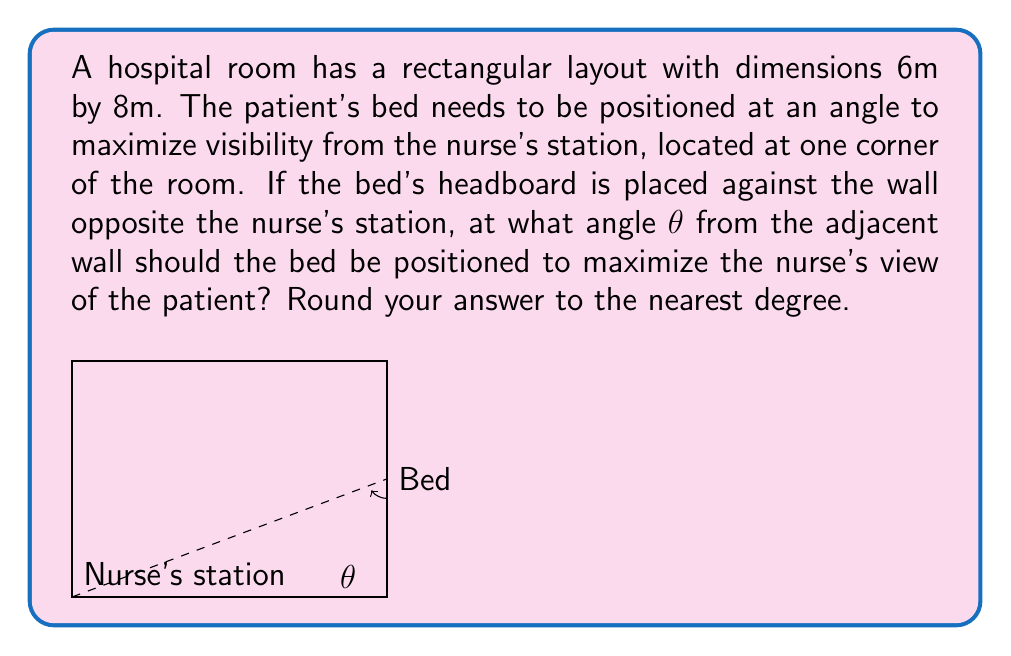Teach me how to tackle this problem. Let's approach this step-by-step:

1) The nurse's station is at one corner (0,0), and the bed's headboard is at the opposite corner (8,6).

2) To maximize visibility, we need to find the angle that creates the longest diagonal from the nurse's station to the bed.

3) The diagonal of the room forms this maximum line of sight. We can calculate this angle using the arctangent function.

4) The tangent of the angle is the ratio of the opposite side to the adjacent side:

   $$ \tan θ = \frac{\text{opposite}}{\text{adjacent}} = \frac{6}{8} = \frac{3}{4} $$

5) To find θ, we take the arctangent (inverse tangent) of this ratio:

   $$ θ = \arctan(\frac{3}{4}) $$

6) Using a calculator or computer:

   $$ θ ≈ 36.87° $$

7) Rounding to the nearest degree:

   $$ θ ≈ 37° $$

Therefore, the bed should be positioned at a 37° angle from the adjacent wall to maximize the nurse's view of the patient.
Answer: 37° 